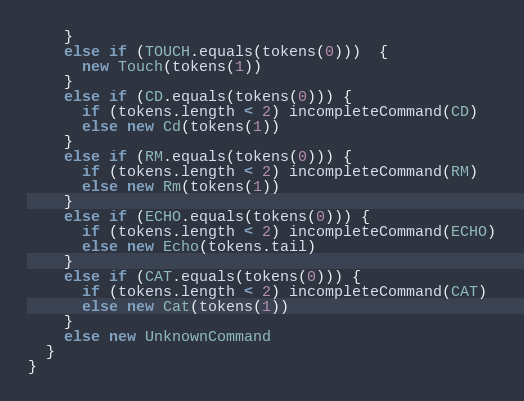<code> <loc_0><loc_0><loc_500><loc_500><_Scala_>    }
    else if (TOUCH.equals(tokens(0)))  {
      new Touch(tokens(1))
    }
    else if (CD.equals(tokens(0))) {
      if (tokens.length < 2) incompleteCommand(CD)
      else new Cd(tokens(1))
    }
    else if (RM.equals(tokens(0))) {
      if (tokens.length < 2) incompleteCommand(RM)
      else new Rm(tokens(1))
    }
    else if (ECHO.equals(tokens(0))) {
      if (tokens.length < 2) incompleteCommand(ECHO)
      else new Echo(tokens.tail)
    }
    else if (CAT.equals(tokens(0))) {
      if (tokens.length < 2) incompleteCommand(CAT)
      else new Cat(tokens(1))
    }
    else new UnknownCommand
  }
}
</code> 